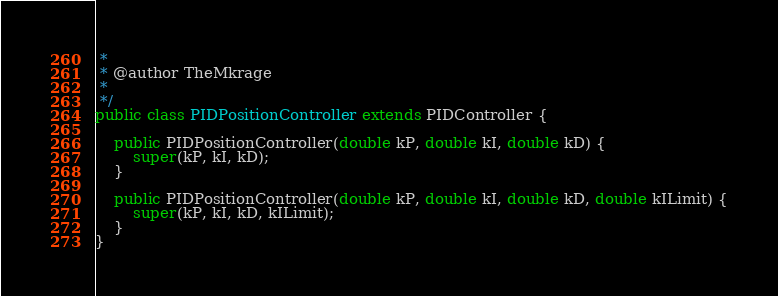Convert code to text. <code><loc_0><loc_0><loc_500><loc_500><_Java_> *
 * @author TheMkrage
 *
 */
public class PIDPositionController extends PIDController {

    public PIDPositionController(double kP, double kI, double kD) {
        super(kP, kI, kD);
    }

    public PIDPositionController(double kP, double kI, double kD, double kILimit) {
        super(kP, kI, kD, kILimit);
    }
}
</code> 